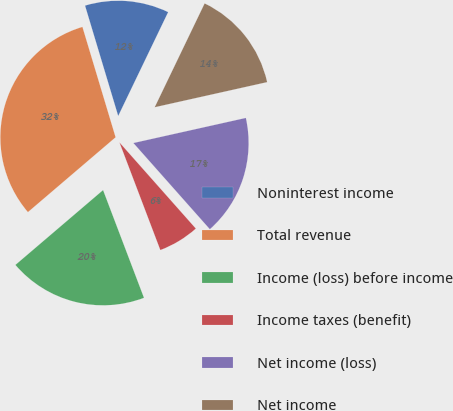Convert chart. <chart><loc_0><loc_0><loc_500><loc_500><pie_chart><fcel>Noninterest income<fcel>Total revenue<fcel>Income (loss) before income<fcel>Income taxes (benefit)<fcel>Net income (loss)<fcel>Net income<nl><fcel>11.78%<fcel>31.6%<fcel>19.53%<fcel>5.77%<fcel>16.95%<fcel>14.37%<nl></chart> 